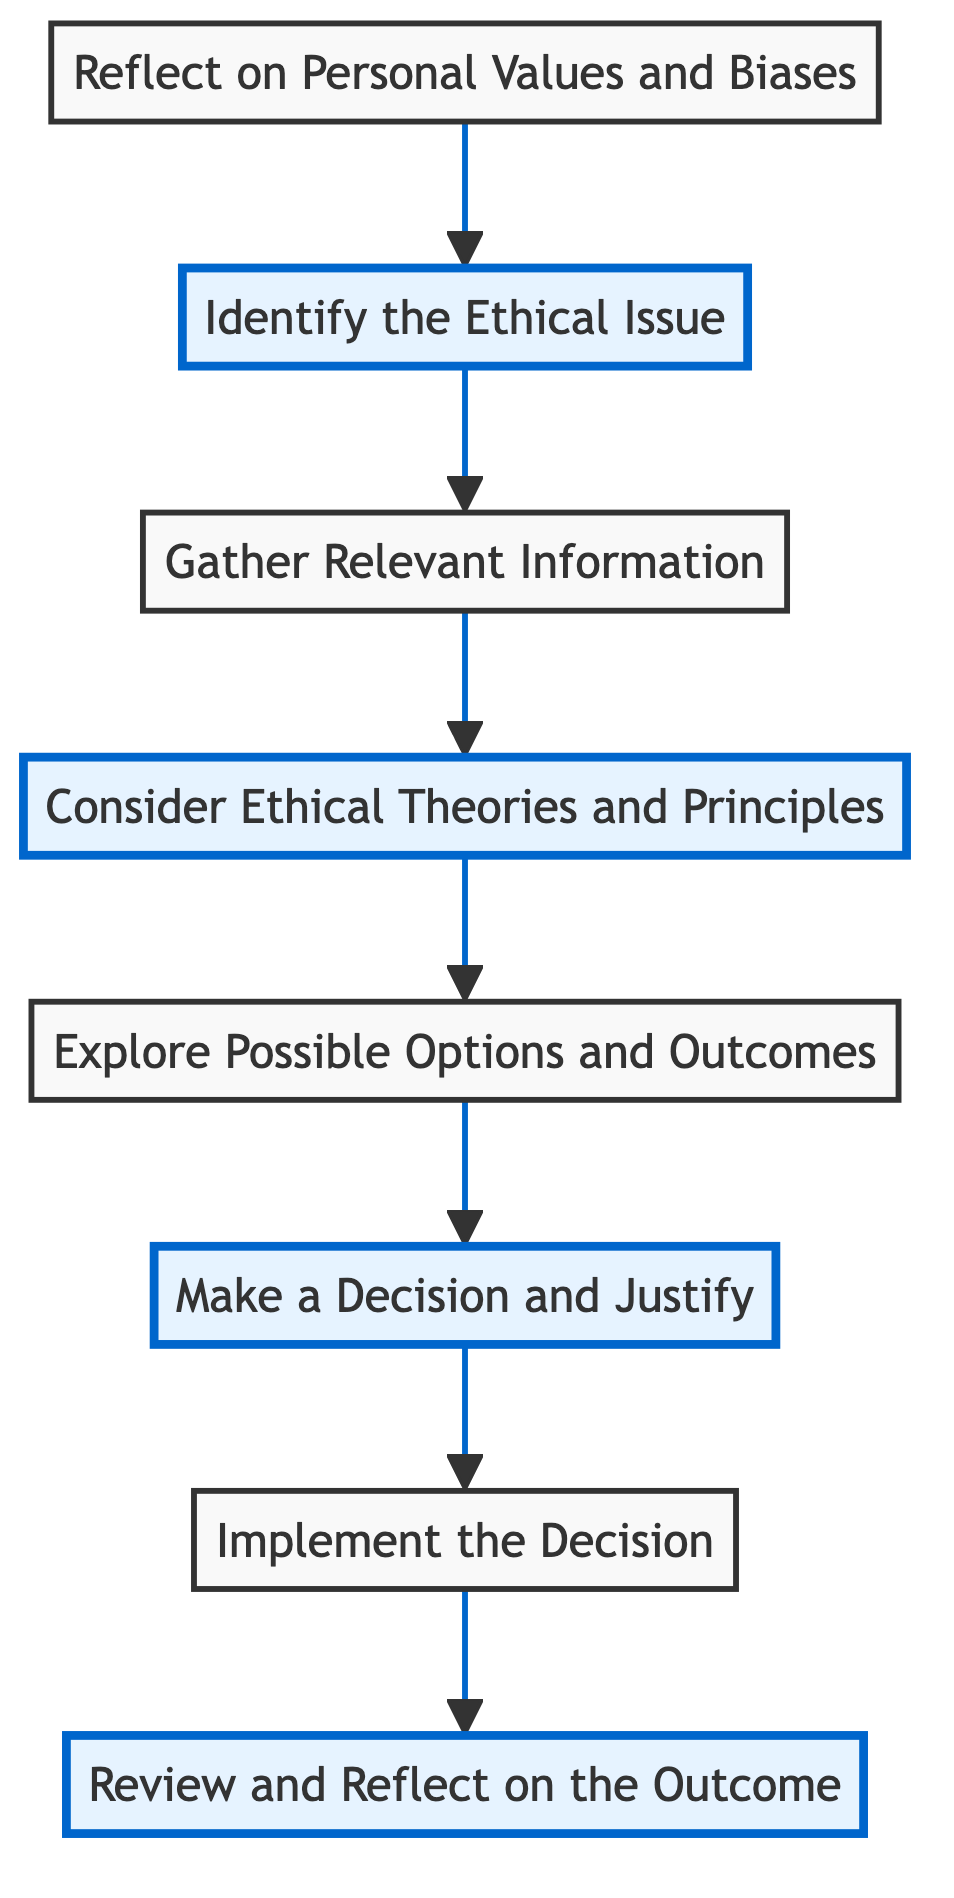What is the first step in the flow chart? The first step in the flow chart is at the bottom, which is represented by the node labeled "Reflect on Personal Values and Biases." This is the initial action one must take before addressing the ethical issue.
Answer: Reflect on Personal Values and Biases How many steps are there in total in the flow chart? Counting the nodes in the flow chart from the bottom to the top gives a total of eight steps, starting from "Reflect on Personal Values and Biases" and ending with "Review and Reflect on the Outcome."
Answer: Eight What is the relationship between "Implement the Decision" and "Make a Decision and Justify"? In the flow chart, "Implement the Decision" directly follows "Make a Decision and Justify," indicating that the decision must be implemented after it has been made and justified.
Answer: Sequential relationship Which step comes immediately after "Consider Ethical Theories and Principles"? According to the flow of the diagram, after "Consider Ethical Theories and Principles," the next step is "Explore Possible Options and Outcomes."
Answer: Explore Possible Options and Outcomes What are the highlighted steps in the flow chart? The highlighted steps are "Review and Reflect on the Outcome," "Make a Decision and Justify," "Consider Ethical Theories and Principles," and "Identify the Ethical Issue." These steps are emphasized by the visual design of the flow chart.
Answer: Review and Reflect on the Outcome, Make a Decision and Justify, Consider Ethical Theories and Principles, Identify the Ethical Issue How does one arrive at the "Review and Reflect on the Outcome"? To arrive at "Review and Reflect on the Outcome," one must follow the flow from the last action taken, which requires implementing a decision made previously. The entire sequence to reach this point involves completing all previous steps, indicating that reflection occurs after taking action.
Answer: By implementing a decision What is the last step in the flow chart? The last step in the flow chart is the node at the very top labeled "Review and Reflect on the Outcome," which signifies the conclusion of the ethical analysis process.
Answer: Review and Reflect on the Outcome What step requires identifying the ethical question? The step that requires identifying the ethical question is "Identify the Ethical Issue," which directly follows the reflection on personal values and biases.
Answer: Identify the Ethical Issue 